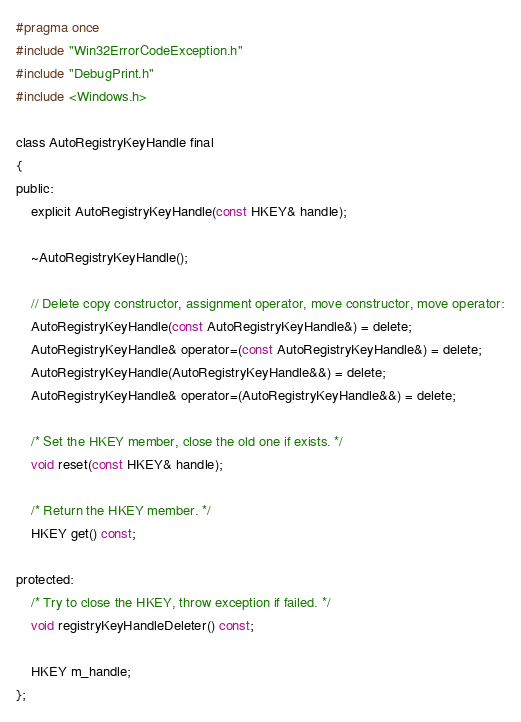Convert code to text. <code><loc_0><loc_0><loc_500><loc_500><_C_>#pragma once
#include "Win32ErrorCodeException.h"
#include "DebugPrint.h"
#include <Windows.h>

class AutoRegistryKeyHandle final
{
public:
	explicit AutoRegistryKeyHandle(const HKEY& handle);

	~AutoRegistryKeyHandle();

	// Delete copy constructor, assignment operator, move constructor, move operator:
	AutoRegistryKeyHandle(const AutoRegistryKeyHandle&) = delete;
	AutoRegistryKeyHandle& operator=(const AutoRegistryKeyHandle&) = delete;
	AutoRegistryKeyHandle(AutoRegistryKeyHandle&&) = delete;
	AutoRegistryKeyHandle& operator=(AutoRegistryKeyHandle&&) = delete;

	/* Set the HKEY member, close the old one if exists. */
	void reset(const HKEY& handle);

	/* Return the HKEY member. */
	HKEY get() const;

protected:
	/* Try to close the HKEY, throw exception if failed. */
	void registryKeyHandleDeleter() const;

	HKEY m_handle;
};</code> 